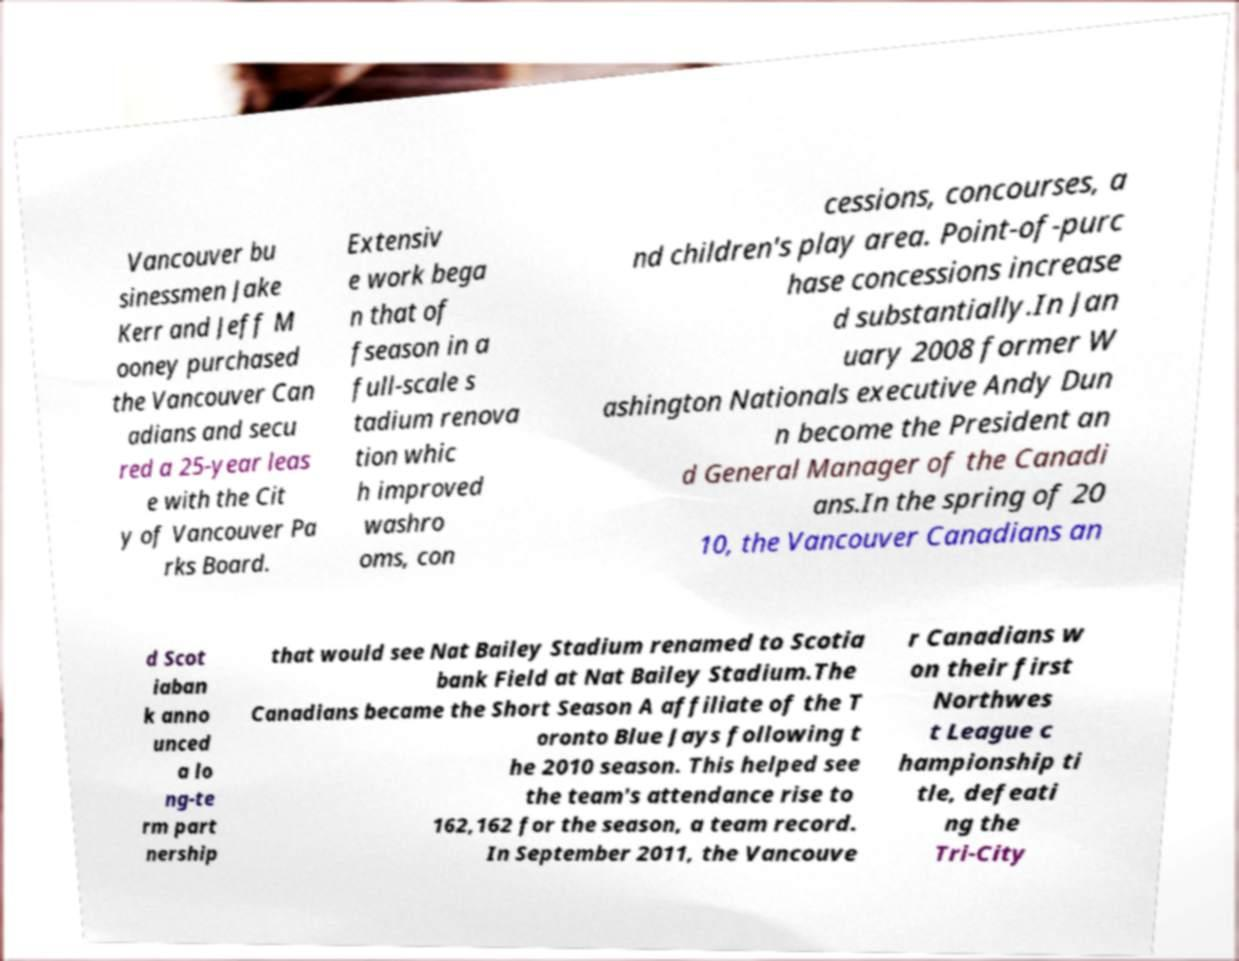What messages or text are displayed in this image? I need them in a readable, typed format. Vancouver bu sinessmen Jake Kerr and Jeff M ooney purchased the Vancouver Can adians and secu red a 25-year leas e with the Cit y of Vancouver Pa rks Board. Extensiv e work bega n that of fseason in a full-scale s tadium renova tion whic h improved washro oms, con cessions, concourses, a nd children's play area. Point-of-purc hase concessions increase d substantially.In Jan uary 2008 former W ashington Nationals executive Andy Dun n become the President an d General Manager of the Canadi ans.In the spring of 20 10, the Vancouver Canadians an d Scot iaban k anno unced a lo ng-te rm part nership that would see Nat Bailey Stadium renamed to Scotia bank Field at Nat Bailey Stadium.The Canadians became the Short Season A affiliate of the T oronto Blue Jays following t he 2010 season. This helped see the team's attendance rise to 162,162 for the season, a team record. In September 2011, the Vancouve r Canadians w on their first Northwes t League c hampionship ti tle, defeati ng the Tri-City 